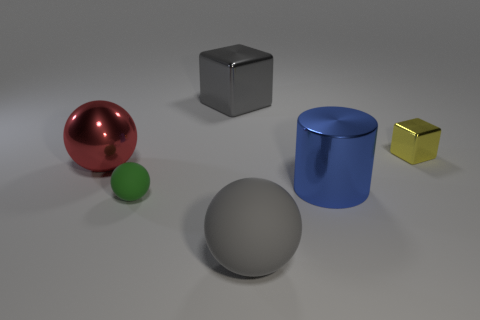Subtract all tiny green rubber balls. How many balls are left? 2 Add 2 tiny things. How many objects exist? 8 Subtract all cylinders. How many objects are left? 5 Subtract all cyan balls. Subtract all green cubes. How many balls are left? 3 Subtract all tiny red rubber objects. Subtract all big gray matte balls. How many objects are left? 5 Add 4 gray spheres. How many gray spheres are left? 5 Add 3 gray matte spheres. How many gray matte spheres exist? 4 Subtract 0 brown blocks. How many objects are left? 6 